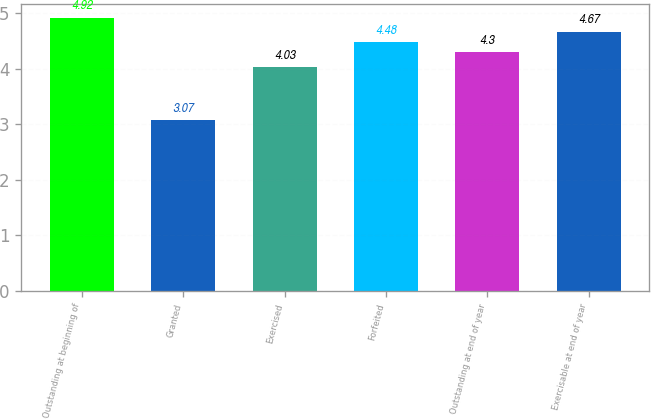Convert chart. <chart><loc_0><loc_0><loc_500><loc_500><bar_chart><fcel>Outstanding at beginning of<fcel>Granted<fcel>Exercised<fcel>Forfeited<fcel>Outstanding at end of year<fcel>Exercisable at end of year<nl><fcel>4.92<fcel>3.07<fcel>4.03<fcel>4.48<fcel>4.3<fcel>4.67<nl></chart> 